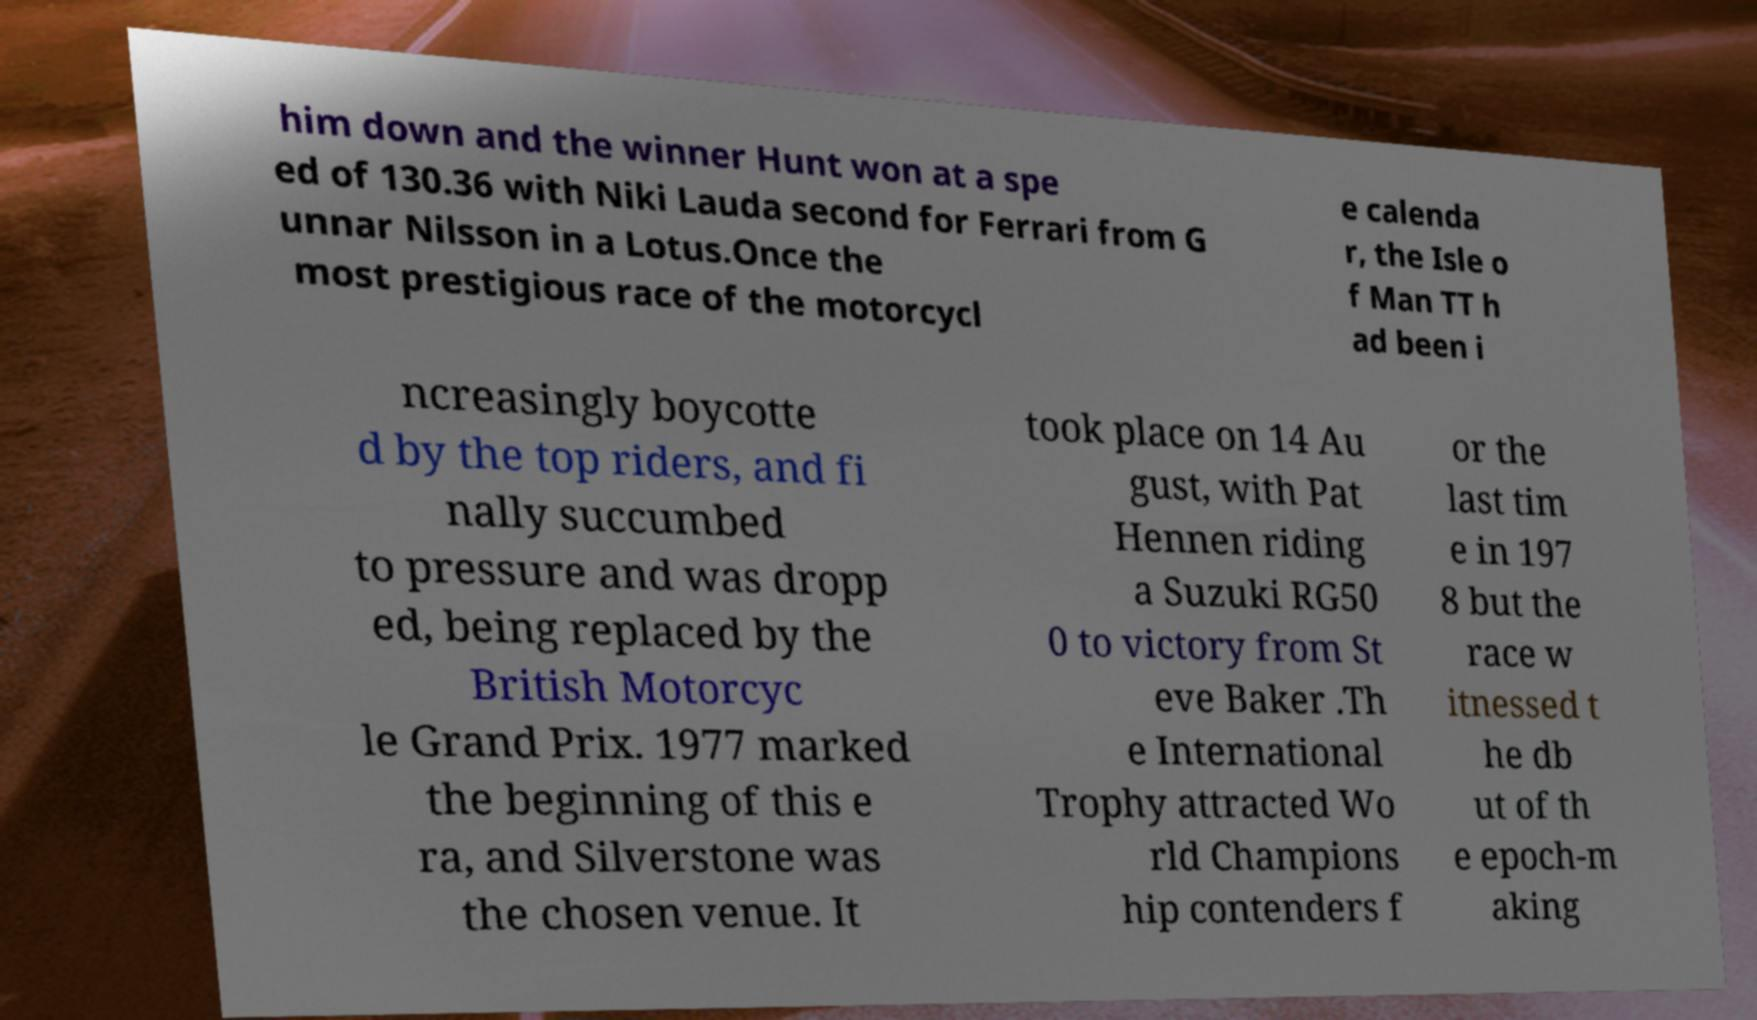Could you assist in decoding the text presented in this image and type it out clearly? him down and the winner Hunt won at a spe ed of 130.36 with Niki Lauda second for Ferrari from G unnar Nilsson in a Lotus.Once the most prestigious race of the motorcycl e calenda r, the Isle o f Man TT h ad been i ncreasingly boycotte d by the top riders, and fi nally succumbed to pressure and was dropp ed, being replaced by the British Motorcyc le Grand Prix. 1977 marked the beginning of this e ra, and Silverstone was the chosen venue. It took place on 14 Au gust, with Pat Hennen riding a Suzuki RG50 0 to victory from St eve Baker .Th e International Trophy attracted Wo rld Champions hip contenders f or the last tim e in 197 8 but the race w itnessed t he db ut of th e epoch-m aking 